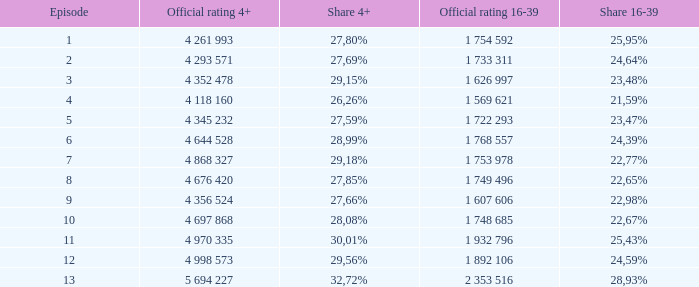What is the official rating 16-39 for the episode with  a 16-39 share of 22,77%? 1 753 978. Can you give me this table as a dict? {'header': ['Episode', 'Official rating 4+', 'Share 4+', 'Official rating 16-39', 'Share 16-39'], 'rows': [['1', '4 261 993', '27,80%', '1 754 592', '25,95%'], ['2', '4 293 571', '27,69%', '1 733 311', '24,64%'], ['3', '4 352 478', '29,15%', '1 626 997', '23,48%'], ['4', '4 118 160', '26,26%', '1 569 621', '21,59%'], ['5', '4 345 232', '27,59%', '1 722 293', '23,47%'], ['6', '4 644 528', '28,99%', '1 768 557', '24,39%'], ['7', '4 868 327', '29,18%', '1 753 978', '22,77%'], ['8', '4 676 420', '27,85%', '1 749 496', '22,65%'], ['9', '4 356 524', '27,66%', '1 607 606', '22,98%'], ['10', '4 697 868', '28,08%', '1 748 685', '22,67%'], ['11', '4 970 335', '30,01%', '1 932 796', '25,43%'], ['12', '4 998 573', '29,56%', '1 892 106', '24,59%'], ['13', '5 694 227', '32,72%', '2 353 516', '28,93%']]} 